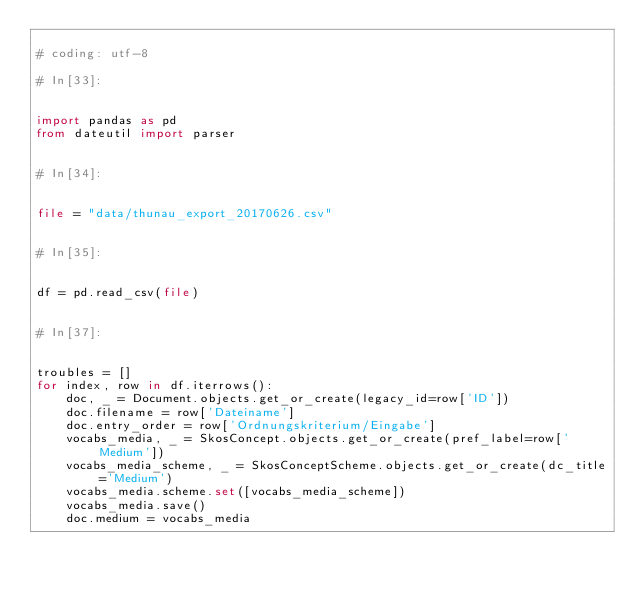<code> <loc_0><loc_0><loc_500><loc_500><_Python_>
# coding: utf-8

# In[33]:


import pandas as pd
from dateutil import parser


# In[34]:


file = "data/thunau_export_20170626.csv"


# In[35]:


df = pd.read_csv(file)


# In[37]:


troubles = []
for index, row in df.iterrows():
    doc, _ = Document.objects.get_or_create(legacy_id=row['ID'])
    doc.filename = row['Dateiname']
    doc.entry_order = row['Ordnungskriterium/Eingabe']
    vocabs_media, _ = SkosConcept.objects.get_or_create(pref_label=row['Medium'])
    vocabs_media_scheme, _ = SkosConceptScheme.objects.get_or_create(dc_title='Medium')
    vocabs_media.scheme.set([vocabs_media_scheme])
    vocabs_media.save()
    doc.medium = vocabs_media</code> 